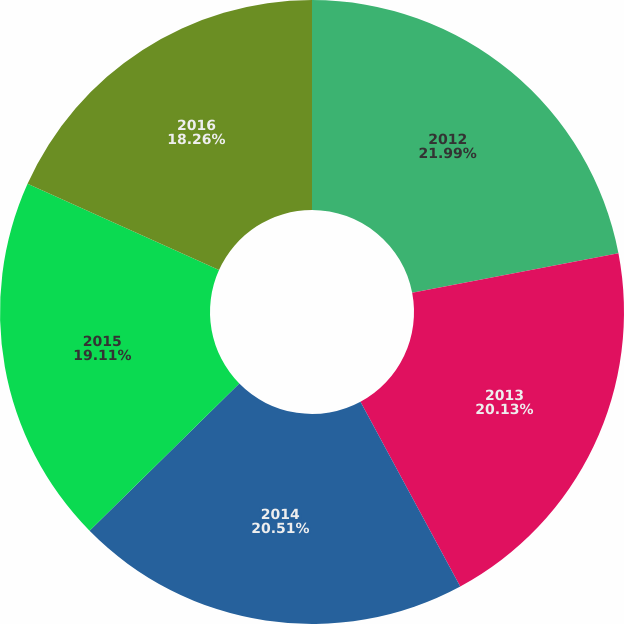Convert chart to OTSL. <chart><loc_0><loc_0><loc_500><loc_500><pie_chart><fcel>2012<fcel>2013<fcel>2014<fcel>2015<fcel>2016<nl><fcel>21.99%<fcel>20.13%<fcel>20.51%<fcel>19.11%<fcel>18.26%<nl></chart> 